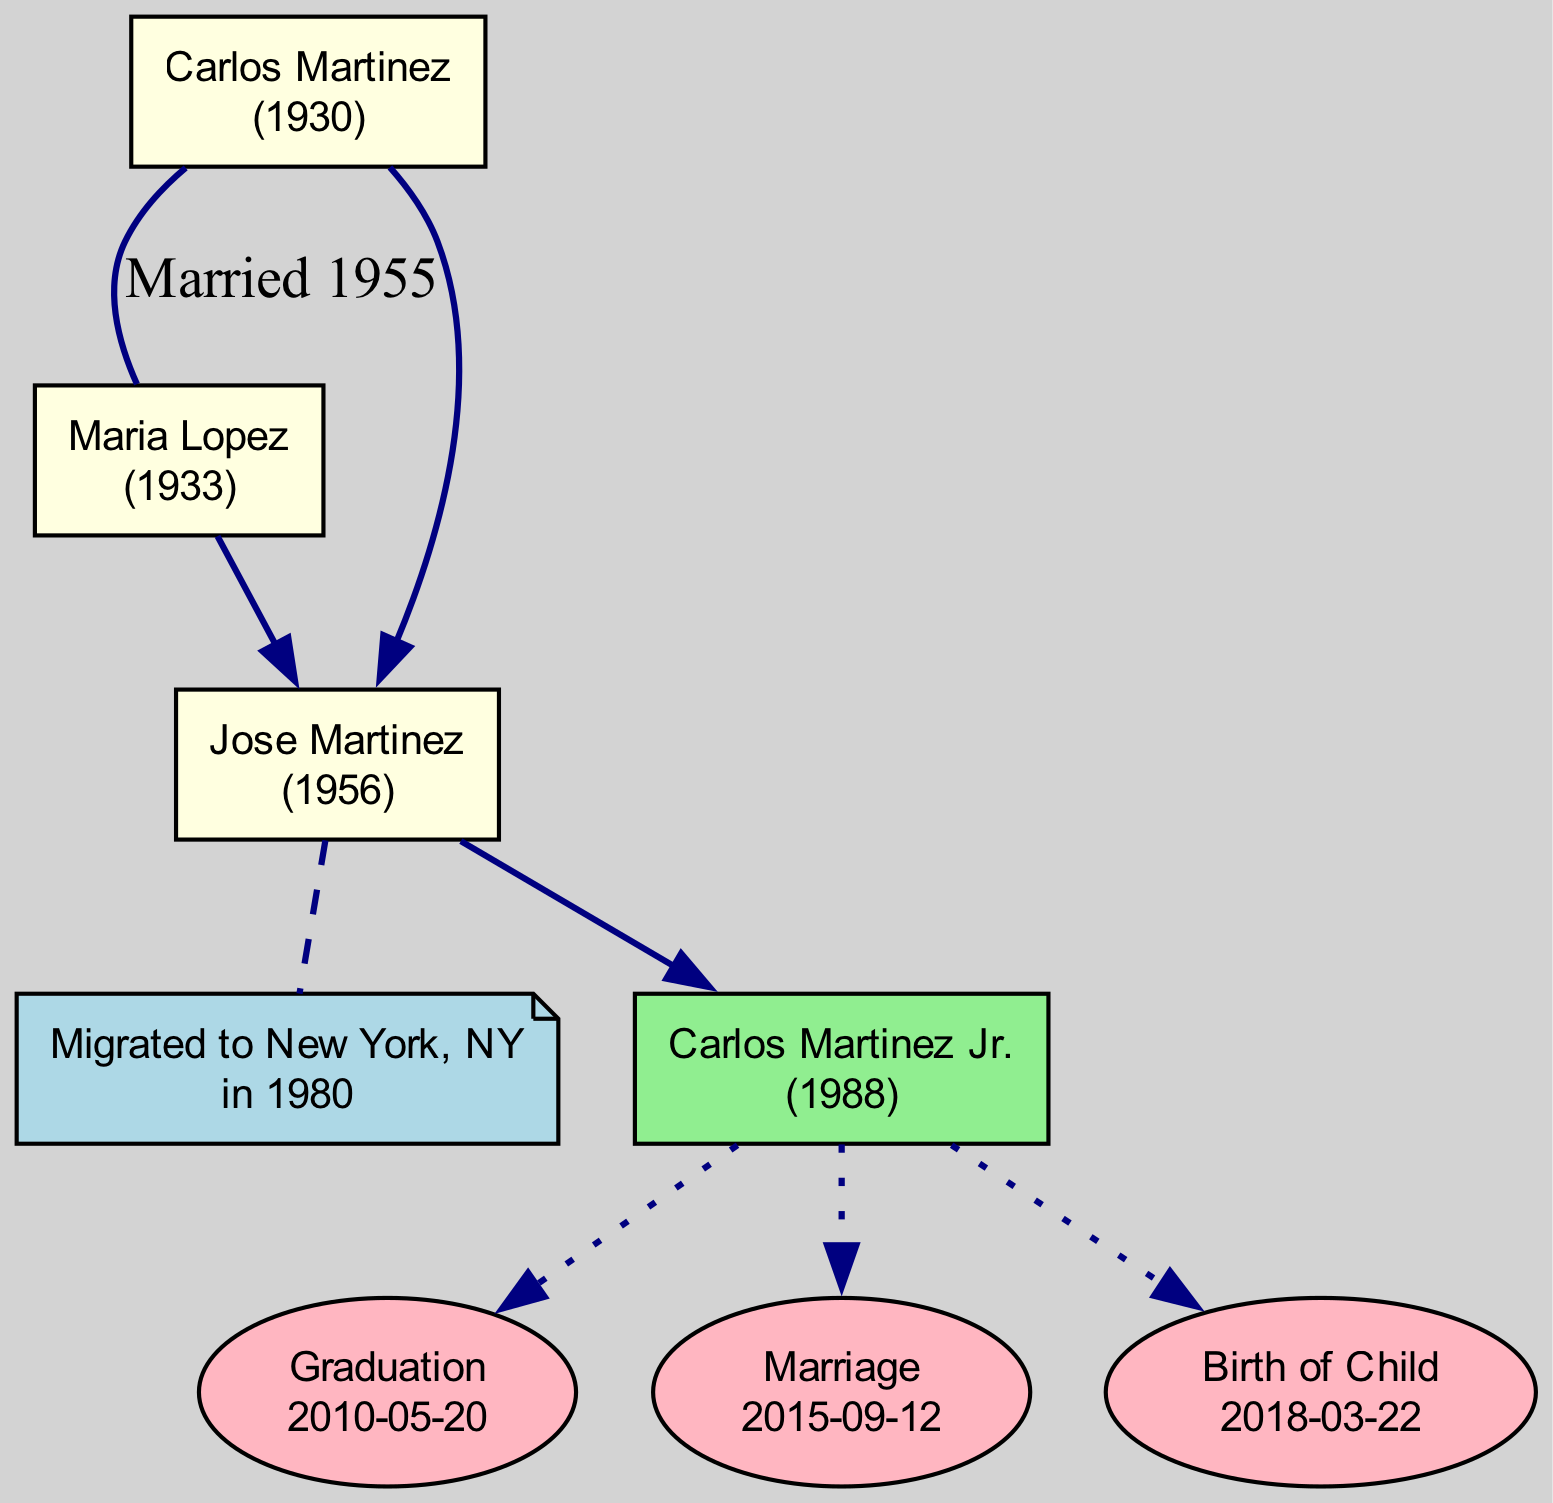What is the birth year of Carlos Martinez? According to the diagram, Carlos Martinez was born in 1930, as indicated right beneath his name.
Answer: 1930 What is the name of Jose Martinez's spouse? The diagram shows that Jose Martinez is married to Elena Rodriguez, details of which are captured in the important events section connecting to Jose.
Answer: Elena Rodriguez Where did the family migrate from? The migration details in the diagram state that the family migrated from Tucson, Arizona, which is mentioned in the migration section of the child node.
Answer: Tucson, Arizona How many children does Carlos Martinez have? The diagram indicates there is one child, Jose Martinez, as shown directly connected beneath the root nodes.
Answer: 1 In what year did Jose Martinez marry Elena Rodriguez? The important event section for Jose Martinez shows that he married Elena Rodriguez in 1985, as stated on the marriage event line.
Answer: 1985 Which generation does Sophia Martinez belong to? Sophia Martinez is indicated as the child of Carlos Martinez Jr., placing her in the current generation, which is specifically noted in the current generation section of the diagram.
Answer: Current generation What is the relationship between Carlos Martinez Jr. and Jose Martinez? The diagram illustrates that Carlos Martinez Jr. is the son of Jose Martinez, making them parent and child, as shown by the direct connection flowing downwards from Jose to Carlos Jr.
Answer: Father and son What significant event occurred for Carlos Martinez Jr. in 2010? The diagram indicates that Carlos Martinez Jr. graduated in 2010, as referenced in the important events listed under his node.
Answer: Graduation How many important events are associated with the current generation? The diagram shows three significant events occurring for Carlos Martinez Jr., which are displayed in the oval nodes under his name.
Answer: 3 